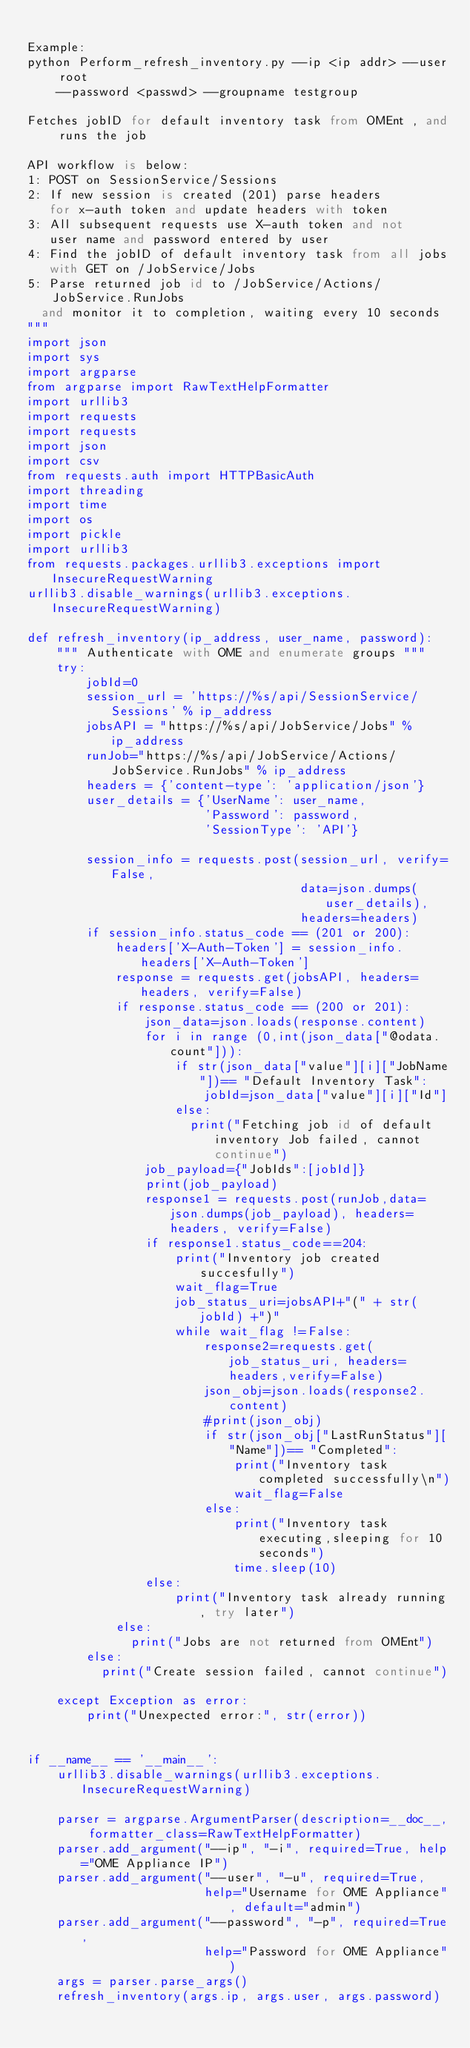<code> <loc_0><loc_0><loc_500><loc_500><_Python_>
Example:
python Perform_refresh_inventory.py --ip <ip addr> --user root
    --password <passwd> --groupname testgroup

Fetches jobID for default inventory task from OMEnt , and runs the job

API workflow is below:
1: POST on SessionService/Sessions
2: If new session is created (201) parse headers
   for x-auth token and update headers with token
3: All subsequent requests use X-auth token and not
   user name and password entered by user
4: Find the jobID of default inventory task from all jobs
   with GET on /JobService/Jobs
5: Parse returned job id to /JobService/Actions/JobService.RunJobs 
	and monitor it to completion, waiting every 10 seconds
"""
import json
import sys
import argparse
from argparse import RawTextHelpFormatter
import urllib3
import requests
import requests
import json
import csv
from requests.auth import HTTPBasicAuth
import threading
import time
import os
import pickle
import urllib3
from requests.packages.urllib3.exceptions import InsecureRequestWarning
urllib3.disable_warnings(urllib3.exceptions.InsecureRequestWarning)

def refresh_inventory(ip_address, user_name, password):
    """ Authenticate with OME and enumerate groups """
    try:
        jobId=0
        session_url = 'https://%s/api/SessionService/Sessions' % ip_address
        jobsAPI = "https://%s/api/JobService/Jobs" % ip_address
        runJob="https://%s/api/JobService/Actions/JobService.RunJobs" % ip_address
        headers = {'content-type': 'application/json'}
        user_details = {'UserName': user_name,
                        'Password': password,
                        'SessionType': 'API'}

        session_info = requests.post(session_url, verify=False,
                                     data=json.dumps(user_details),
                                     headers=headers)
        if session_info.status_code == (201 or 200):
            headers['X-Auth-Token'] = session_info.headers['X-Auth-Token']
            response = requests.get(jobsAPI, headers=headers, verify=False)
            if response.status_code == (200 or 201):
                json_data=json.loads(response.content)
                for i in range (0,int(json_data["@odata.count"])):
                    if str(json_data["value"][i]["JobName"])== "Default Inventory Task":
                        jobId=json_data["value"][i]["Id"]
                    else:
                    	print("Fetching job id of default inventory Job failed, cannot continue")
                job_payload={"JobIds":[jobId]}
                print(job_payload)
                response1 = requests.post(runJob,data=json.dumps(job_payload), headers=headers, verify=False)
                if response1.status_code==204:
                    print("Inventory job created succesfully")
                    wait_flag=True
                    job_status_uri=jobsAPI+"(" + str(jobId) +")"
                    while wait_flag !=False:
                        response2=requests.get(job_status_uri, headers=headers,verify=False)
                        json_obj=json.loads(response2.content)
                        #print(json_obj)
                        if str(json_obj["LastRunStatus"]["Name"])== "Completed":
                            print("Inventory task completed successfully\n")
                            wait_flag=False
                        else:
                            print("Inventory task executing,sleeping for 10 seconds")
                            time.sleep(10)
                else:
                    print("Inventory task already running, try later")
            else:
            	print("Jobs are not returned from OMEnt")
        else:
        	print("Create session failed, cannot continue")

    except Exception as error:
        print("Unexpected error:", str(error))


if __name__ == '__main__':
    urllib3.disable_warnings(urllib3.exceptions.InsecureRequestWarning)

    parser = argparse.ArgumentParser(description=__doc__, formatter_class=RawTextHelpFormatter)
    parser.add_argument("--ip", "-i", required=True, help="OME Appliance IP")
    parser.add_argument("--user", "-u", required=True,
                        help="Username for OME Appliance", default="admin")
    parser.add_argument("--password", "-p", required=True,
                        help="Password for OME Appliance")
    args = parser.parse_args()
    refresh_inventory(args.ip, args.user, args.password)</code> 